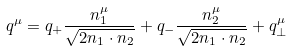Convert formula to latex. <formula><loc_0><loc_0><loc_500><loc_500>q ^ { \mu } = q _ { + } \frac { n _ { 1 } ^ { \mu } } { \sqrt { 2 n _ { 1 } \cdot n _ { 2 } } } + q _ { - } \frac { n _ { 2 } ^ { \mu } } { \sqrt { 2 n _ { 1 } \cdot n _ { 2 } } } + q _ { \perp } ^ { \mu }</formula> 